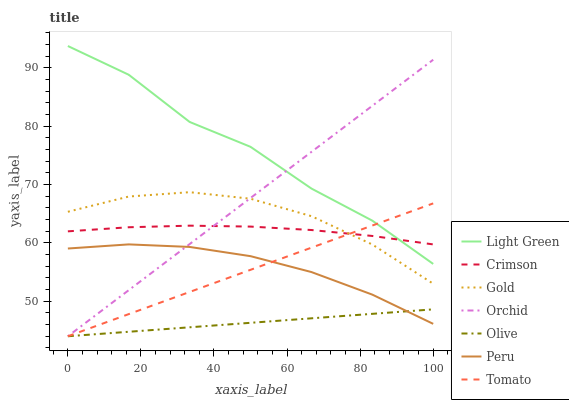Does Olive have the minimum area under the curve?
Answer yes or no. Yes. Does Light Green have the maximum area under the curve?
Answer yes or no. Yes. Does Gold have the minimum area under the curve?
Answer yes or no. No. Does Gold have the maximum area under the curve?
Answer yes or no. No. Is Olive the smoothest?
Answer yes or no. Yes. Is Light Green the roughest?
Answer yes or no. Yes. Is Gold the smoothest?
Answer yes or no. No. Is Gold the roughest?
Answer yes or no. No. Does Tomato have the lowest value?
Answer yes or no. Yes. Does Light Green have the lowest value?
Answer yes or no. No. Does Light Green have the highest value?
Answer yes or no. Yes. Does Gold have the highest value?
Answer yes or no. No. Is Olive less than Gold?
Answer yes or no. Yes. Is Gold greater than Peru?
Answer yes or no. Yes. Does Tomato intersect Crimson?
Answer yes or no. Yes. Is Tomato less than Crimson?
Answer yes or no. No. Is Tomato greater than Crimson?
Answer yes or no. No. Does Olive intersect Gold?
Answer yes or no. No. 